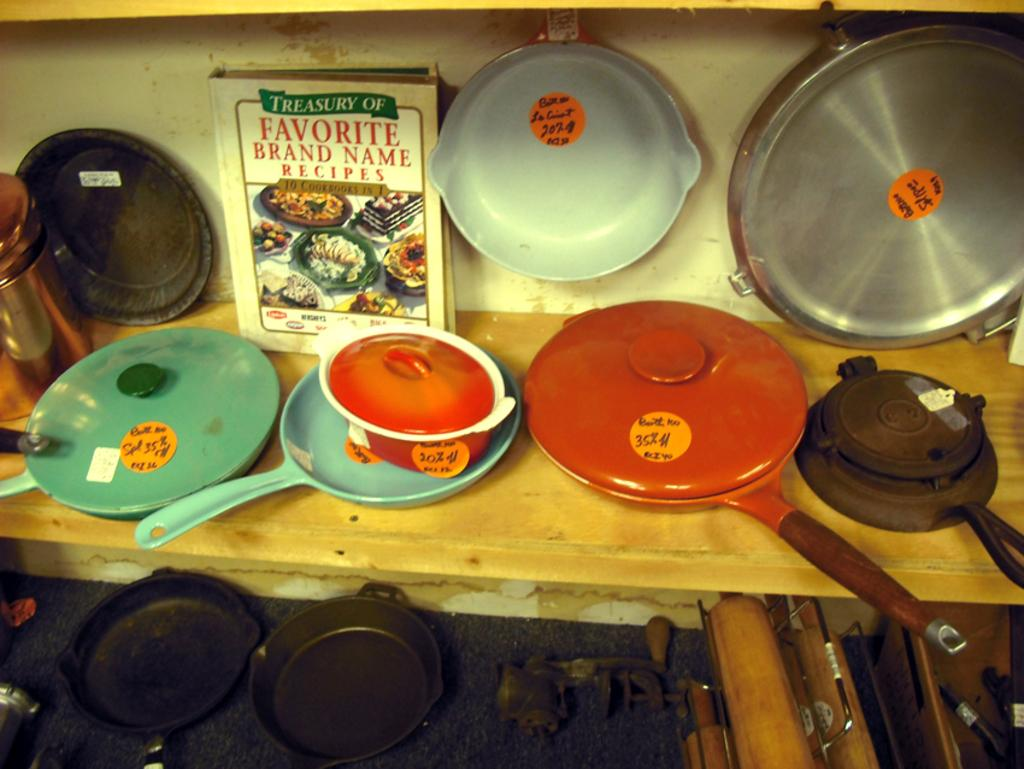What type of objects can be seen in the image? There are many plants, kitchen instruments, and a recipe book in the image. Can you describe the plants in the image? The image contains many plants, but their specific types cannot be determined from the provided facts. What might the recipe book be used for? The recipe book in the image might be used for cooking or baking. What type of chalk can be seen on the mountain in the image? There is no chalk or mountain present in the image. How many men are visible in the image? There is no mention of men in the provided facts, so it cannot be determined from the image. 